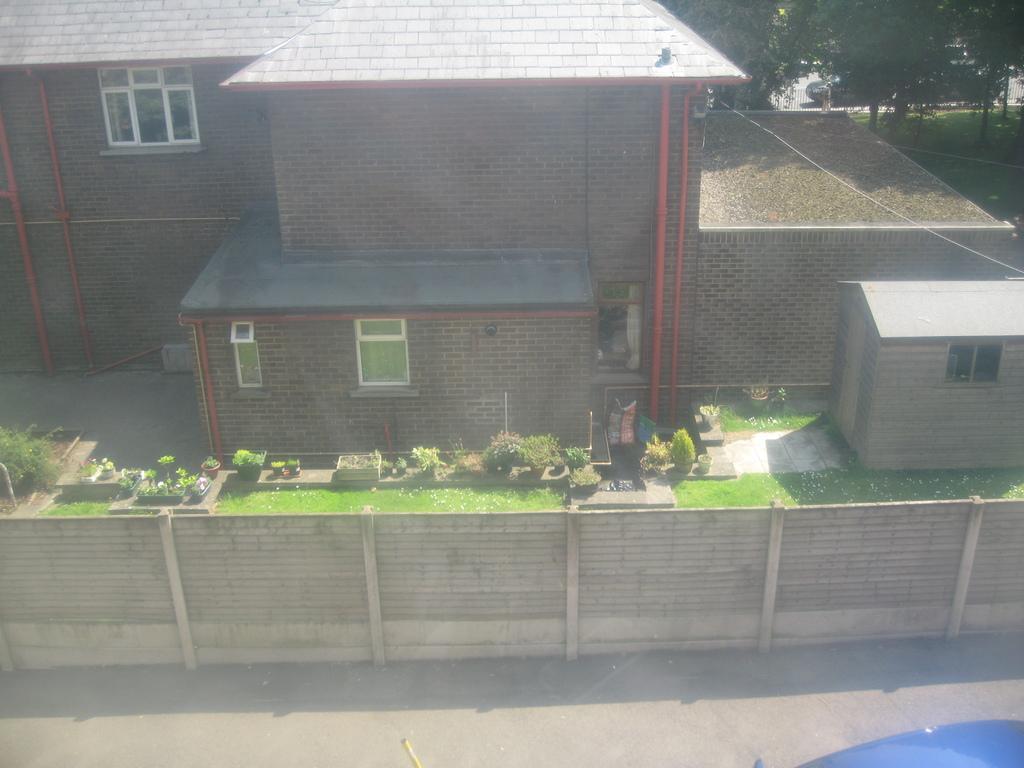How would you summarize this image in a sentence or two? In this picture we can see a vehicle on the road, fence, plants, house with windows, pipes and in the background we can see trees. 